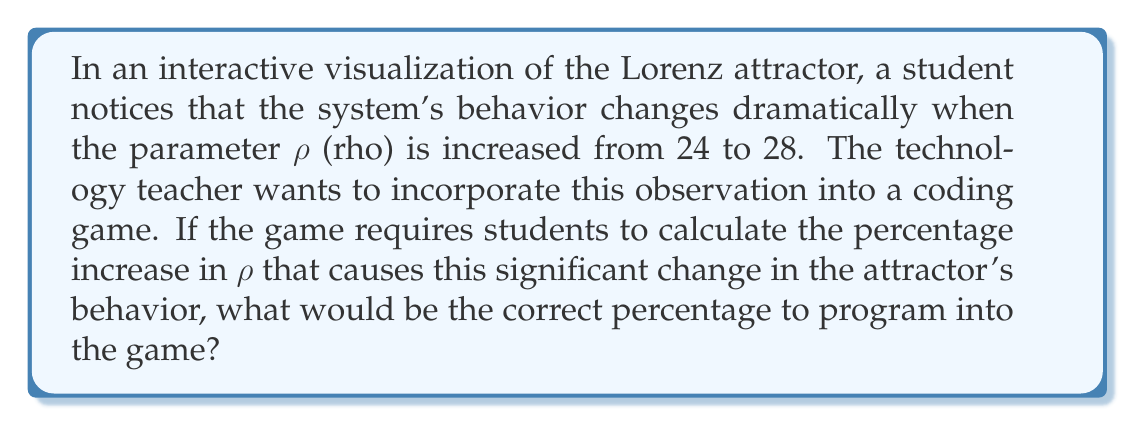Could you help me with this problem? To solve this problem, we need to calculate the percentage increase from the initial value of $\rho$ to its new value. Let's break it down step-by-step:

1. Initial value of $\rho$: 24
2. New value of $\rho$: 28

To calculate the percentage increase, we use the formula:

$$ \text{Percentage Increase} = \frac{\text{Increase}}{\text{Original Value}} \times 100\% $$

3. Calculate the increase:
   $\text{Increase} = 28 - 24 = 4$

4. Apply the formula:
   $$ \text{Percentage Increase} = \frac{4}{24} \times 100\% $$

5. Simplify the fraction:
   $$ \text{Percentage Increase} = \frac{1}{6} \times 100\% $$

6. Calculate the final percentage:
   $$ \text{Percentage Increase} = 16.67\% $$

Rounding to two decimal places gives us 16.67%.
Answer: 16.67% 